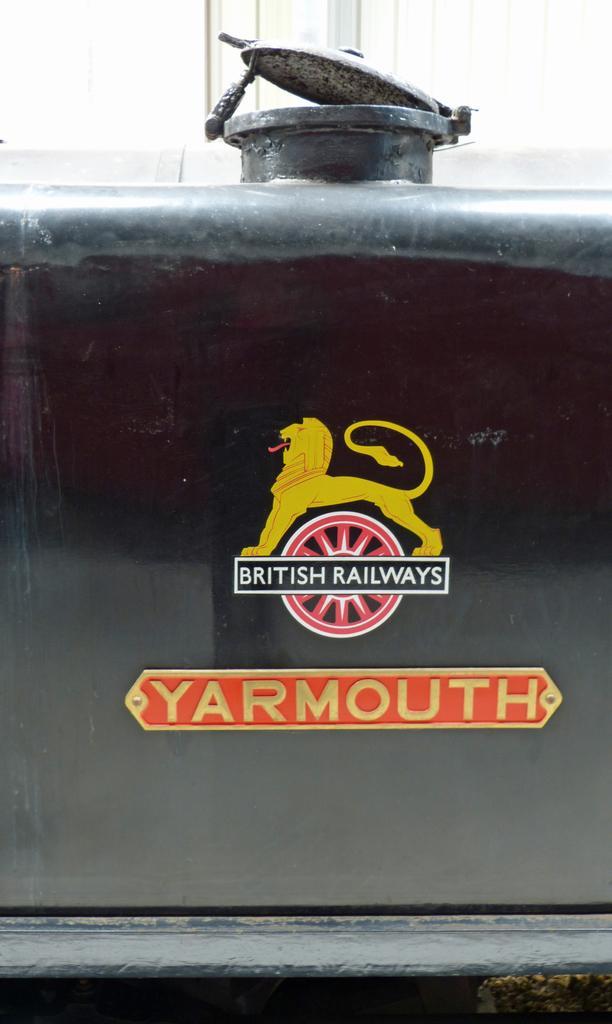Can you describe this image briefly? In this picture we can see a name board and a logo on a tank with a lid and in the background we can see windows. 